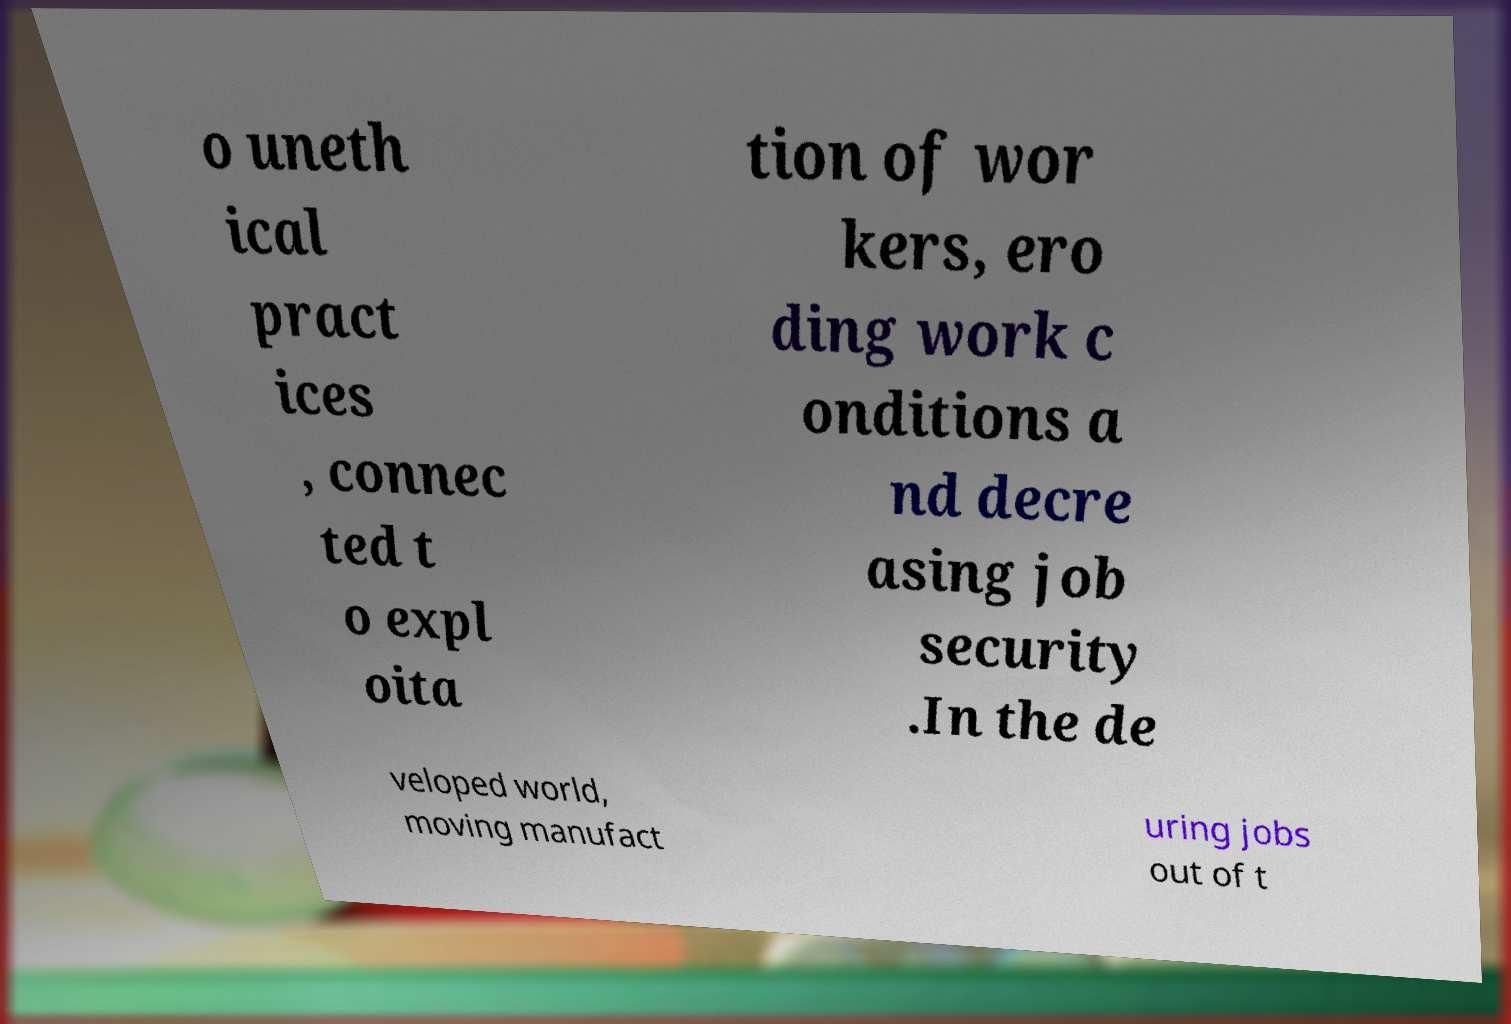What messages or text are displayed in this image? I need them in a readable, typed format. o uneth ical pract ices , connec ted t o expl oita tion of wor kers, ero ding work c onditions a nd decre asing job security .In the de veloped world, moving manufact uring jobs out of t 